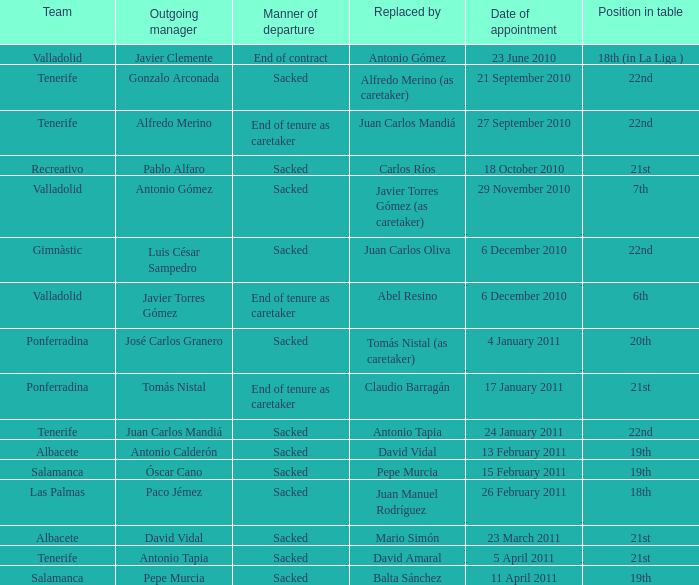How many teams had an appointment date of 11 april 2011 1.0. 